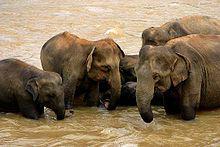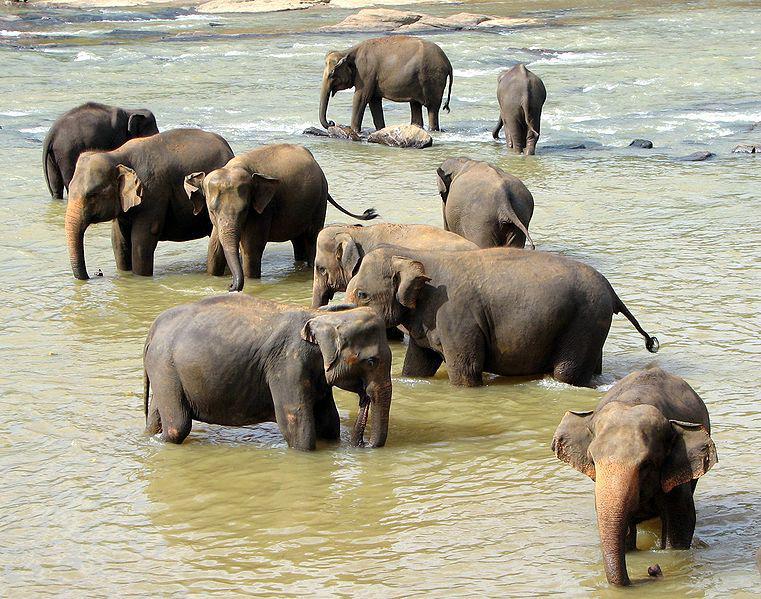The first image is the image on the left, the second image is the image on the right. Assess this claim about the two images: "An image shows at least ten elephants completely surrounded by water.". Correct or not? Answer yes or no. Yes. The first image is the image on the left, the second image is the image on the right. Considering the images on both sides, is "Several elephants are in the water." valid? Answer yes or no. Yes. 